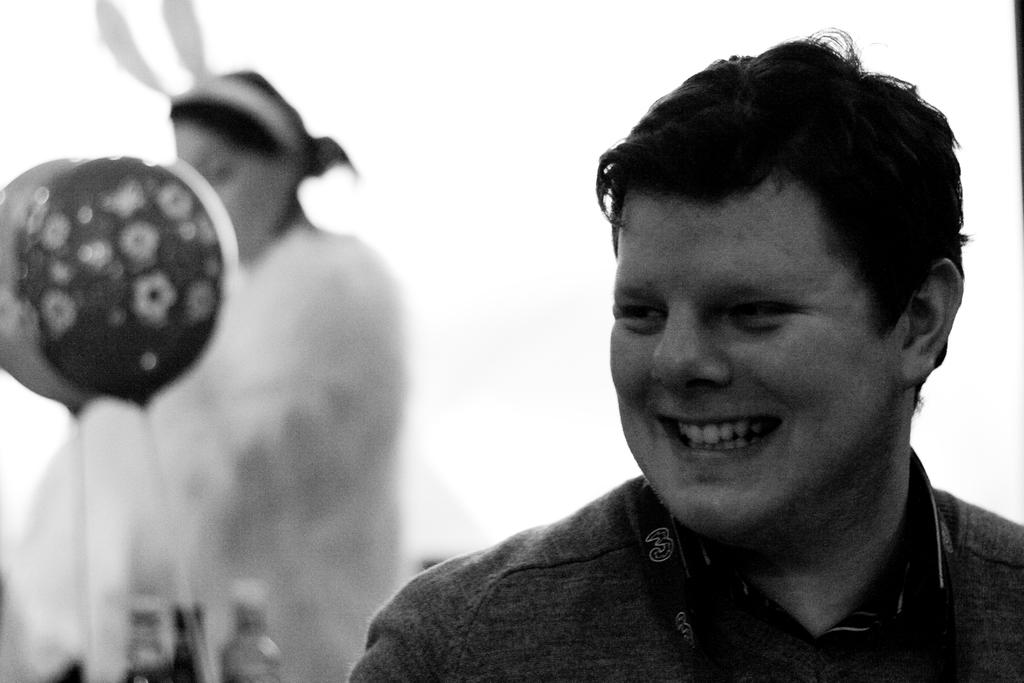What is the gender of the person in the picture? There is a man in the picture. What is the man doing in the picture? The man is smiling and looking to the left. What is the woman wearing in the picture? The woman is wearing a white dress. What is the woman's posture in the picture? The woman is standing. What is the color of the background in the image? The background of the image is white. What book is the man reading in the image? There is no book present in the image, and the man is not reading. What shape is the woman's smile in the image? The woman's smile is not described in terms of shape in the image; it is simply mentioned that she is smiling. 